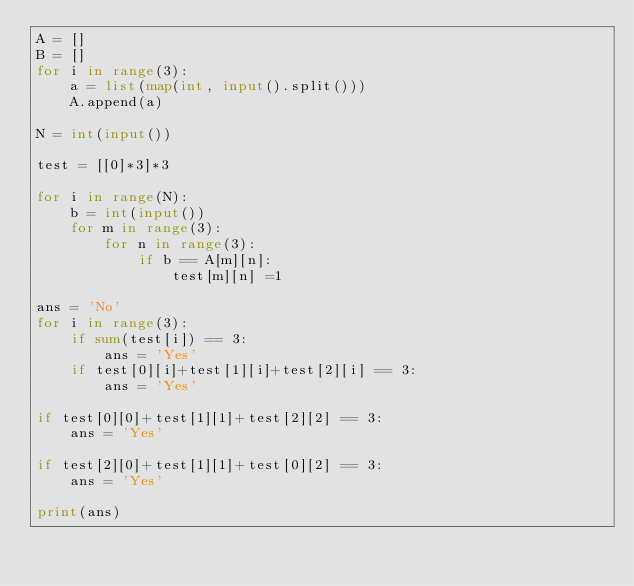Convert code to text. <code><loc_0><loc_0><loc_500><loc_500><_Python_>A = []
B = []
for i in range(3):
    a = list(map(int, input().split()))
    A.append(a)

N = int(input())

test = [[0]*3]*3

for i in range(N):
    b = int(input())
    for m in range(3):
        for n in range(3):
            if b == A[m][n]:
                test[m][n] =1

ans = 'No'
for i in range(3):
    if sum(test[i]) == 3:
        ans = 'Yes'
    if test[0][i]+test[1][i]+test[2][i] == 3:
        ans = 'Yes'

if test[0][0]+test[1][1]+test[2][2] == 3:
    ans = 'Yes'

if test[2][0]+test[1][1]+test[0][2] == 3:
    ans = 'Yes'

print(ans)
</code> 